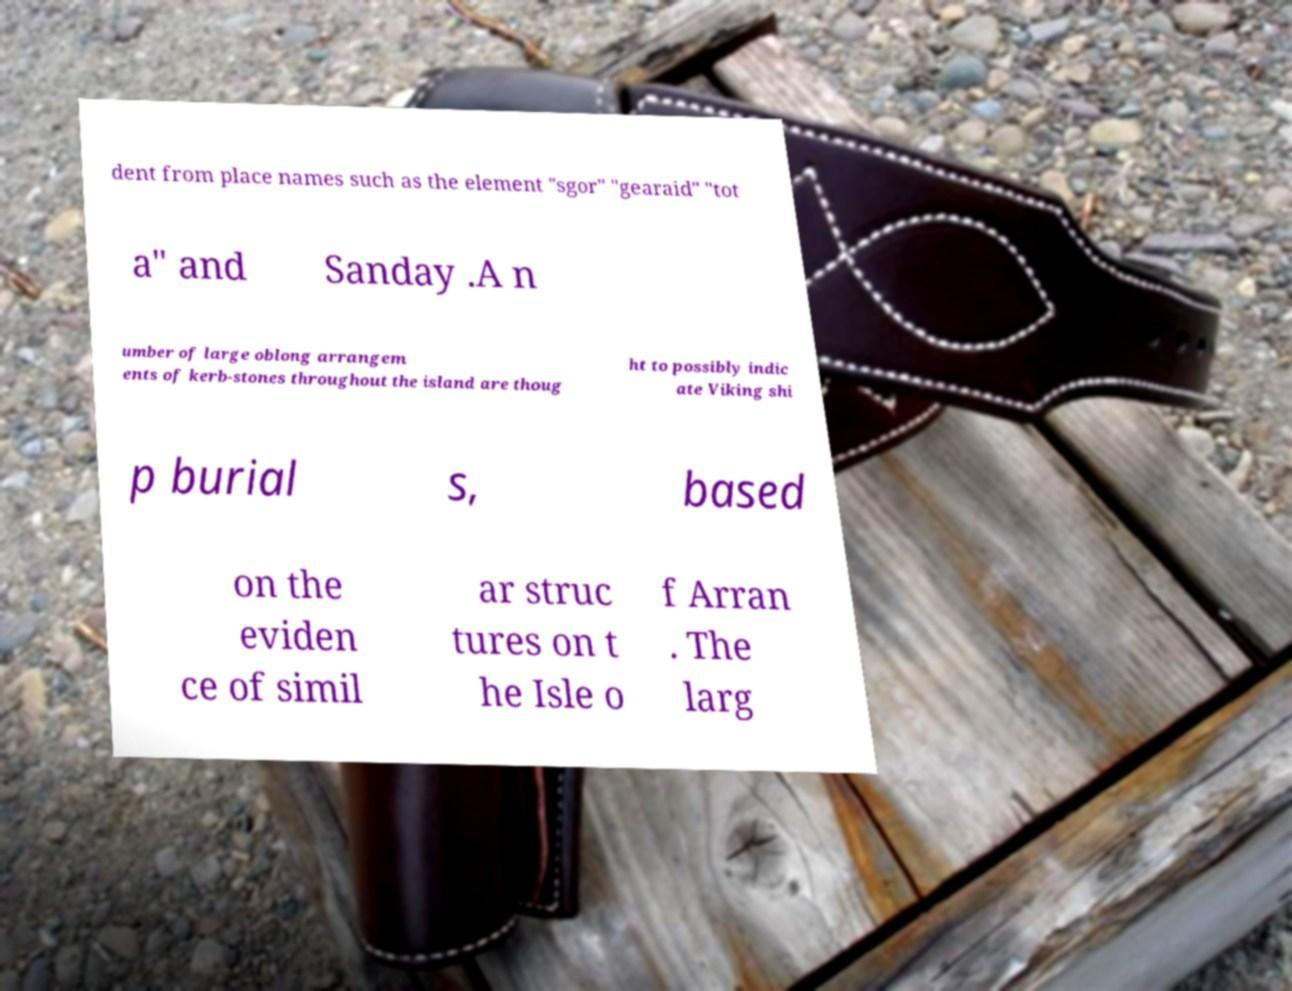Can you accurately transcribe the text from the provided image for me? dent from place names such as the element "sgor" "gearaid" "tot a" and Sanday .A n umber of large oblong arrangem ents of kerb-stones throughout the island are thoug ht to possibly indic ate Viking shi p burial s, based on the eviden ce of simil ar struc tures on t he Isle o f Arran . The larg 